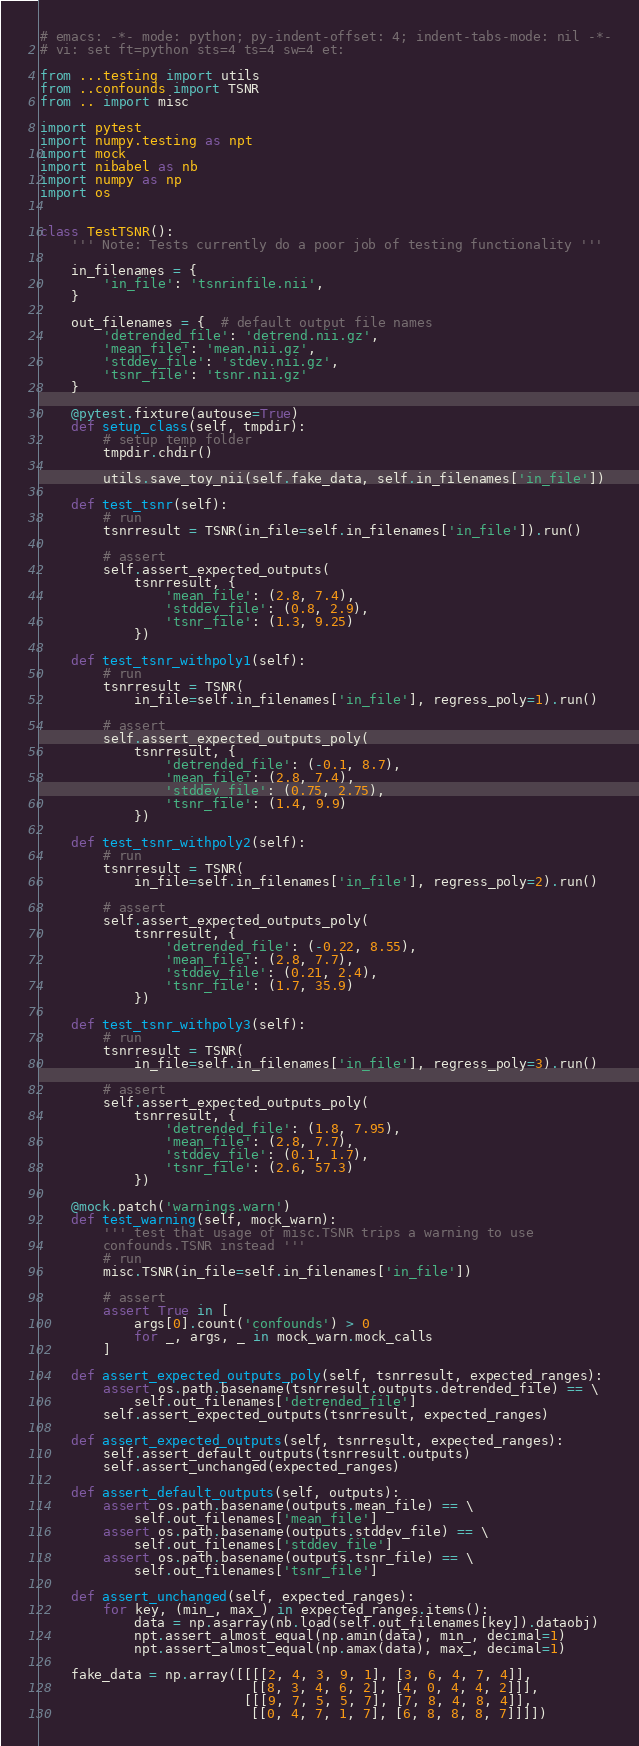<code> <loc_0><loc_0><loc_500><loc_500><_Python_># emacs: -*- mode: python; py-indent-offset: 4; indent-tabs-mode: nil -*-
# vi: set ft=python sts=4 ts=4 sw=4 et:

from ...testing import utils
from ..confounds import TSNR
from .. import misc

import pytest
import numpy.testing as npt
import mock
import nibabel as nb
import numpy as np
import os


class TestTSNR():
    ''' Note: Tests currently do a poor job of testing functionality '''

    in_filenames = {
        'in_file': 'tsnrinfile.nii',
    }

    out_filenames = {  # default output file names
        'detrended_file': 'detrend.nii.gz',
        'mean_file': 'mean.nii.gz',
        'stddev_file': 'stdev.nii.gz',
        'tsnr_file': 'tsnr.nii.gz'
    }

    @pytest.fixture(autouse=True)
    def setup_class(self, tmpdir):
        # setup temp folder
        tmpdir.chdir()

        utils.save_toy_nii(self.fake_data, self.in_filenames['in_file'])

    def test_tsnr(self):
        # run
        tsnrresult = TSNR(in_file=self.in_filenames['in_file']).run()

        # assert
        self.assert_expected_outputs(
            tsnrresult, {
                'mean_file': (2.8, 7.4),
                'stddev_file': (0.8, 2.9),
                'tsnr_file': (1.3, 9.25)
            })

    def test_tsnr_withpoly1(self):
        # run
        tsnrresult = TSNR(
            in_file=self.in_filenames['in_file'], regress_poly=1).run()

        # assert
        self.assert_expected_outputs_poly(
            tsnrresult, {
                'detrended_file': (-0.1, 8.7),
                'mean_file': (2.8, 7.4),
                'stddev_file': (0.75, 2.75),
                'tsnr_file': (1.4, 9.9)
            })

    def test_tsnr_withpoly2(self):
        # run
        tsnrresult = TSNR(
            in_file=self.in_filenames['in_file'], regress_poly=2).run()

        # assert
        self.assert_expected_outputs_poly(
            tsnrresult, {
                'detrended_file': (-0.22, 8.55),
                'mean_file': (2.8, 7.7),
                'stddev_file': (0.21, 2.4),
                'tsnr_file': (1.7, 35.9)
            })

    def test_tsnr_withpoly3(self):
        # run
        tsnrresult = TSNR(
            in_file=self.in_filenames['in_file'], regress_poly=3).run()

        # assert
        self.assert_expected_outputs_poly(
            tsnrresult, {
                'detrended_file': (1.8, 7.95),
                'mean_file': (2.8, 7.7),
                'stddev_file': (0.1, 1.7),
                'tsnr_file': (2.6, 57.3)
            })

    @mock.patch('warnings.warn')
    def test_warning(self, mock_warn):
        ''' test that usage of misc.TSNR trips a warning to use
        confounds.TSNR instead '''
        # run
        misc.TSNR(in_file=self.in_filenames['in_file'])

        # assert
        assert True in [
            args[0].count('confounds') > 0
            for _, args, _ in mock_warn.mock_calls
        ]

    def assert_expected_outputs_poly(self, tsnrresult, expected_ranges):
        assert os.path.basename(tsnrresult.outputs.detrended_file) == \
            self.out_filenames['detrended_file']
        self.assert_expected_outputs(tsnrresult, expected_ranges)

    def assert_expected_outputs(self, tsnrresult, expected_ranges):
        self.assert_default_outputs(tsnrresult.outputs)
        self.assert_unchanged(expected_ranges)

    def assert_default_outputs(self, outputs):
        assert os.path.basename(outputs.mean_file) == \
            self.out_filenames['mean_file']
        assert os.path.basename(outputs.stddev_file) == \
            self.out_filenames['stddev_file']
        assert os.path.basename(outputs.tsnr_file) == \
            self.out_filenames['tsnr_file']

    def assert_unchanged(self, expected_ranges):
        for key, (min_, max_) in expected_ranges.items():
            data = np.asarray(nb.load(self.out_filenames[key]).dataobj)
            npt.assert_almost_equal(np.amin(data), min_, decimal=1)
            npt.assert_almost_equal(np.amax(data), max_, decimal=1)

    fake_data = np.array([[[[2, 4, 3, 9, 1], [3, 6, 4, 7, 4]],
                           [[8, 3, 4, 6, 2], [4, 0, 4, 4, 2]]],
                          [[[9, 7, 5, 5, 7], [7, 8, 4, 8, 4]],
                           [[0, 4, 7, 1, 7], [6, 8, 8, 8, 7]]]])
</code> 